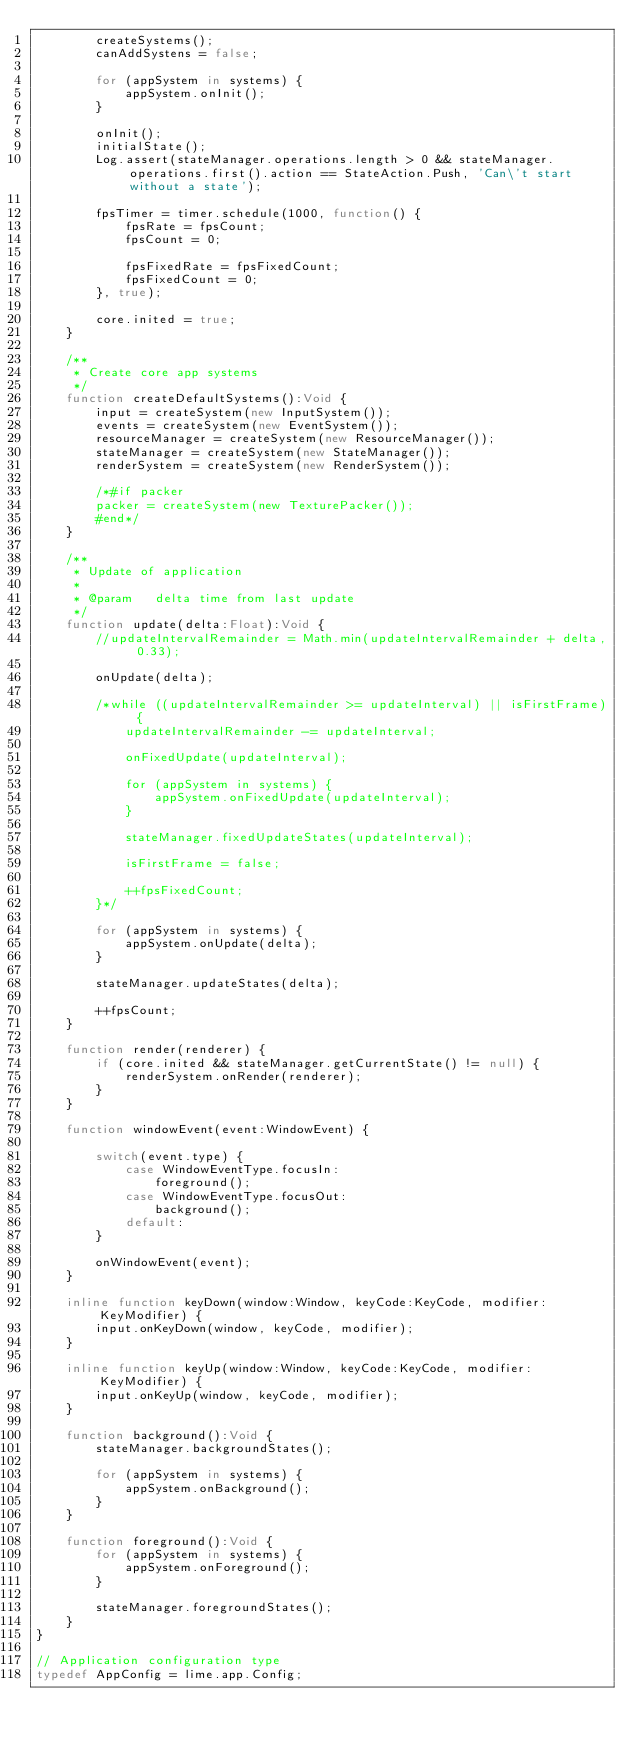<code> <loc_0><loc_0><loc_500><loc_500><_Haxe_>		createSystems();
		canAddSystens = false;
		
		for (appSystem in systems) {
			appSystem.onInit();
		}

		onInit();
		initialState();
		Log.assert(stateManager.operations.length > 0 && stateManager.operations.first().action == StateAction.Push, 'Can\'t start without a state');
		
		fpsTimer = timer.schedule(1000, function() {
			fpsRate = fpsCount;
			fpsCount = 0;

			fpsFixedRate = fpsFixedCount;
			fpsFixedCount = 0;
		}, true);
		
		core.inited = true;
	}

	/**
	 * Create core app systems
	 */
	function createDefaultSystems():Void {
		input = createSystem(new InputSystem());
		events = createSystem(new EventSystem());
		resourceManager = createSystem(new ResourceManager());
		stateManager = createSystem(new StateManager());
		renderSystem = createSystem(new RenderSystem());

		/*#if packer
		packer = createSystem(new TexturePacker());
		#end*/
	}

	/**
	 * Update of application
	 *
	 * @param	delta time from last update
	 */
	function update(delta:Float):Void {
		//updateIntervalRemainder = Math.min(updateIntervalRemainder + delta, 0.33);
		
		onUpdate(delta);
		
		/*while ((updateIntervalRemainder >= updateInterval) || isFirstFrame) {
			updateIntervalRemainder -= updateInterval;

			onFixedUpdate(updateInterval);
			
			for (appSystem in systems) {
				appSystem.onFixedUpdate(updateInterval);
			}

			stateManager.fixedUpdateStates(updateInterval);

			isFirstFrame = false;

			++fpsFixedCount;
		}*/

		for (appSystem in systems) {
			appSystem.onUpdate(delta);
		}

		stateManager.updateStates(delta);
		
		++fpsCount;
	}
	
	function render(renderer) {
		if (core.inited && stateManager.getCurrentState() != null) {
			renderSystem.onRender(renderer);
		}
	}
	
	function windowEvent(event:WindowEvent) {
		
		switch(event.type) {
			case WindowEventType.focusIn:
				foreground();
			case WindowEventType.focusOut:
				background();
			default:
		}
		
		onWindowEvent(event);
	}
	
	inline function keyDown(window:Window, keyCode:KeyCode, modifier:KeyModifier) {
		input.onKeyDown(window, keyCode, modifier);
	}
	
	inline function keyUp(window:Window, keyCode:KeyCode, modifier:KeyModifier) {
		input.onKeyUp(window, keyCode, modifier);
	}
	
	function background():Void {
		stateManager.backgroundStates();

		for (appSystem in systems) {
			appSystem.onBackground();
		}
	}

	function foreground():Void {
		for (appSystem in systems) {
			appSystem.onForeground();
		}

		stateManager.foregroundStates();
	}
}

// Application configuration type
typedef AppConfig = lime.app.Config;</code> 